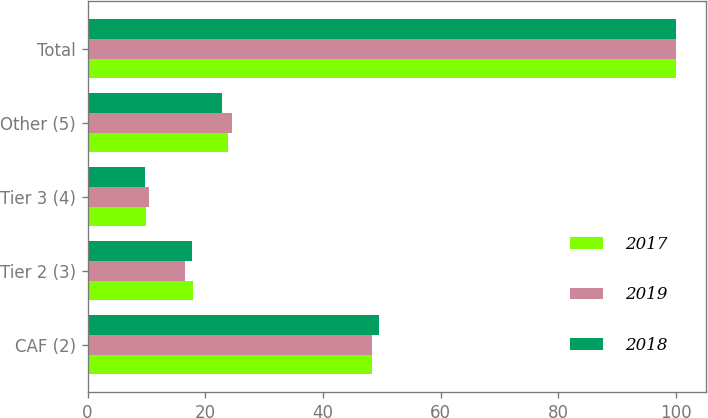<chart> <loc_0><loc_0><loc_500><loc_500><stacked_bar_chart><ecel><fcel>CAF (2)<fcel>Tier 2 (3)<fcel>Tier 3 (4)<fcel>Other (5)<fcel>Total<nl><fcel>2017<fcel>48.4<fcel>17.9<fcel>9.9<fcel>23.8<fcel>100<nl><fcel>2019<fcel>48.4<fcel>16.6<fcel>10.5<fcel>24.5<fcel>100<nl><fcel>2018<fcel>49.5<fcel>17.8<fcel>9.8<fcel>22.9<fcel>100<nl></chart> 